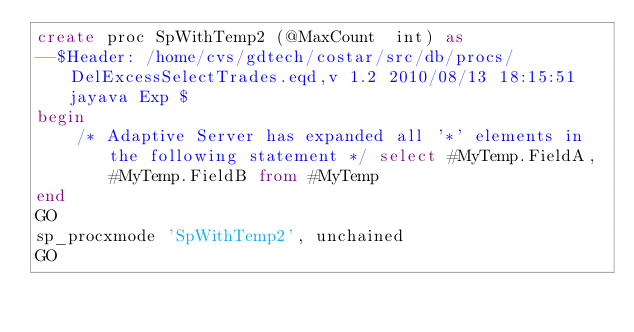<code> <loc_0><loc_0><loc_500><loc_500><_SQL_>create proc SpWithTemp2 (@MaxCount  int) as
--$Header: /home/cvs/gdtech/costar/src/db/procs/DelExcessSelectTrades.eqd,v 1.2 2010/08/13 18:15:51 jayava Exp $
begin
    /* Adaptive Server has expanded all '*' elements in the following statement */ select #MyTemp.FieldA, #MyTemp.FieldB from #MyTemp
end
GO
sp_procxmode 'SpWithTemp2', unchained
GO</code> 